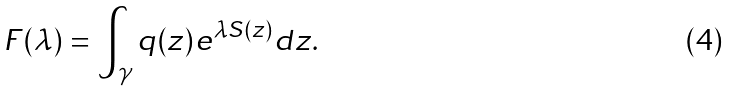Convert formula to latex. <formula><loc_0><loc_0><loc_500><loc_500>F ( \lambda ) = \int _ { \gamma } q ( z ) e ^ { \lambda S ( z ) } d z .</formula> 